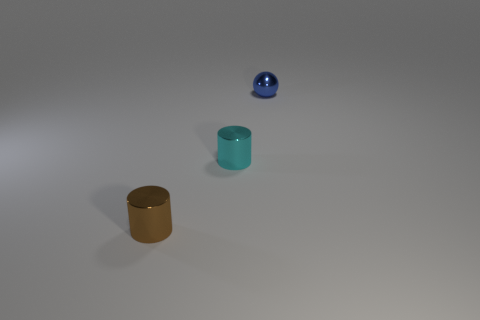Add 3 big green matte balls. How many objects exist? 6 Add 1 small blue objects. How many small blue objects are left? 2 Add 3 big purple matte things. How many big purple matte things exist? 3 Subtract 0 cyan spheres. How many objects are left? 3 Subtract all cylinders. How many objects are left? 1 Subtract all purple cylinders. Subtract all red balls. How many cylinders are left? 2 Subtract all large cyan spheres. Subtract all metallic cylinders. How many objects are left? 1 